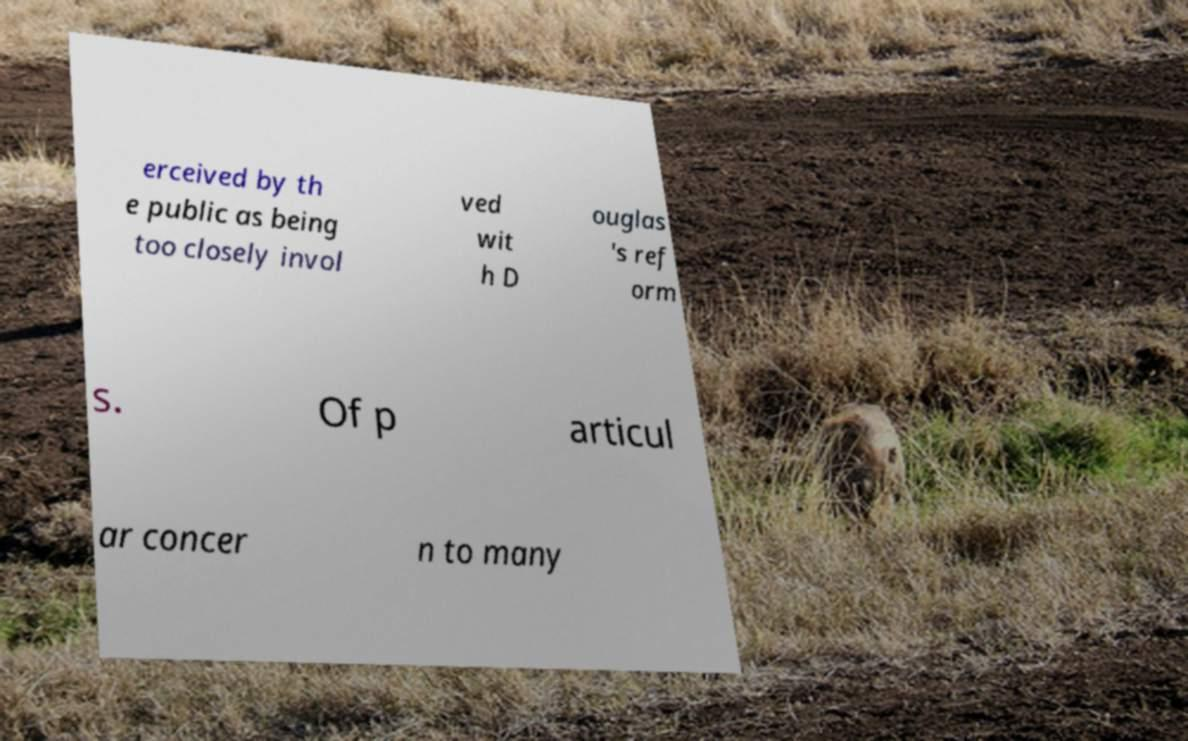I need the written content from this picture converted into text. Can you do that? erceived by th e public as being too closely invol ved wit h D ouglas 's ref orm s. Of p articul ar concer n to many 